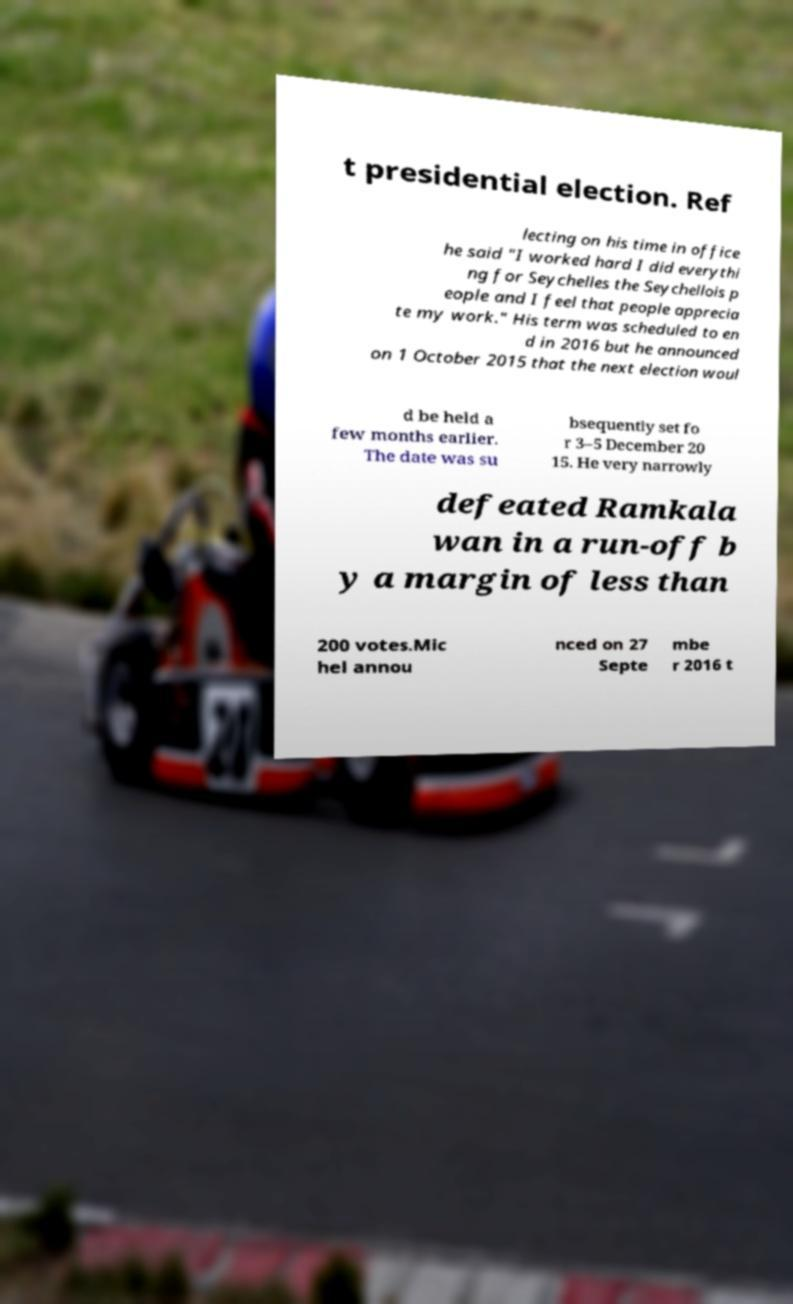Could you extract and type out the text from this image? t presidential election. Ref lecting on his time in office he said "I worked hard I did everythi ng for Seychelles the Seychellois p eople and I feel that people apprecia te my work." His term was scheduled to en d in 2016 but he announced on 1 October 2015 that the next election woul d be held a few months earlier. The date was su bsequently set fo r 3–5 December 20 15. He very narrowly defeated Ramkala wan in a run-off b y a margin of less than 200 votes.Mic hel annou nced on 27 Septe mbe r 2016 t 